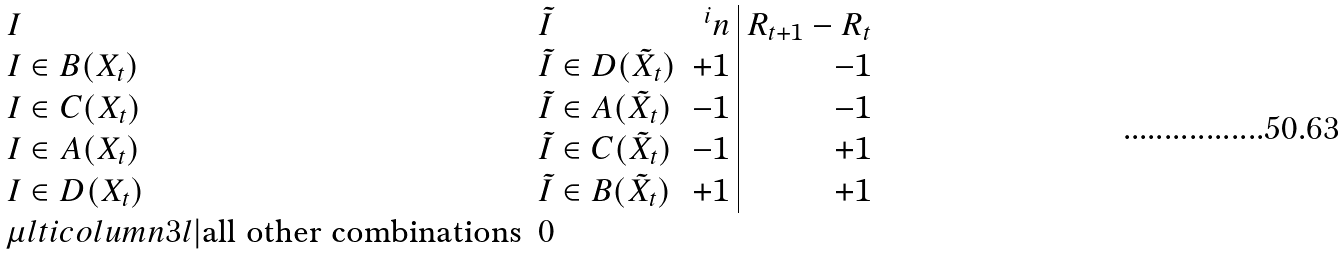Convert formula to latex. <formula><loc_0><loc_0><loc_500><loc_500>\begin{array} { l l r | r } I & \tilde { I } & ^ { i } n & R _ { t + 1 } - R _ { t } \\ I \in B ( X _ { t } ) & \tilde { I } \in D ( \tilde { X } _ { t } ) & + 1 & - 1 \\ I \in C ( X _ { t } ) & \tilde { I } \in A ( \tilde { X } _ { t } ) & - 1 & - 1 \\ I \in A ( { X } _ { t } ) & \tilde { I } \in C ( \tilde { X } _ { t } ) & - 1 & + 1 \\ I \in D ( X _ { t } ) & \tilde { I } \in B ( \tilde { X } _ { t } ) & + 1 & + 1 \\ \mu l t i c o l u m n { 3 } { l | } { \text {all other combinations} } & 0 \\ \end{array}</formula> 